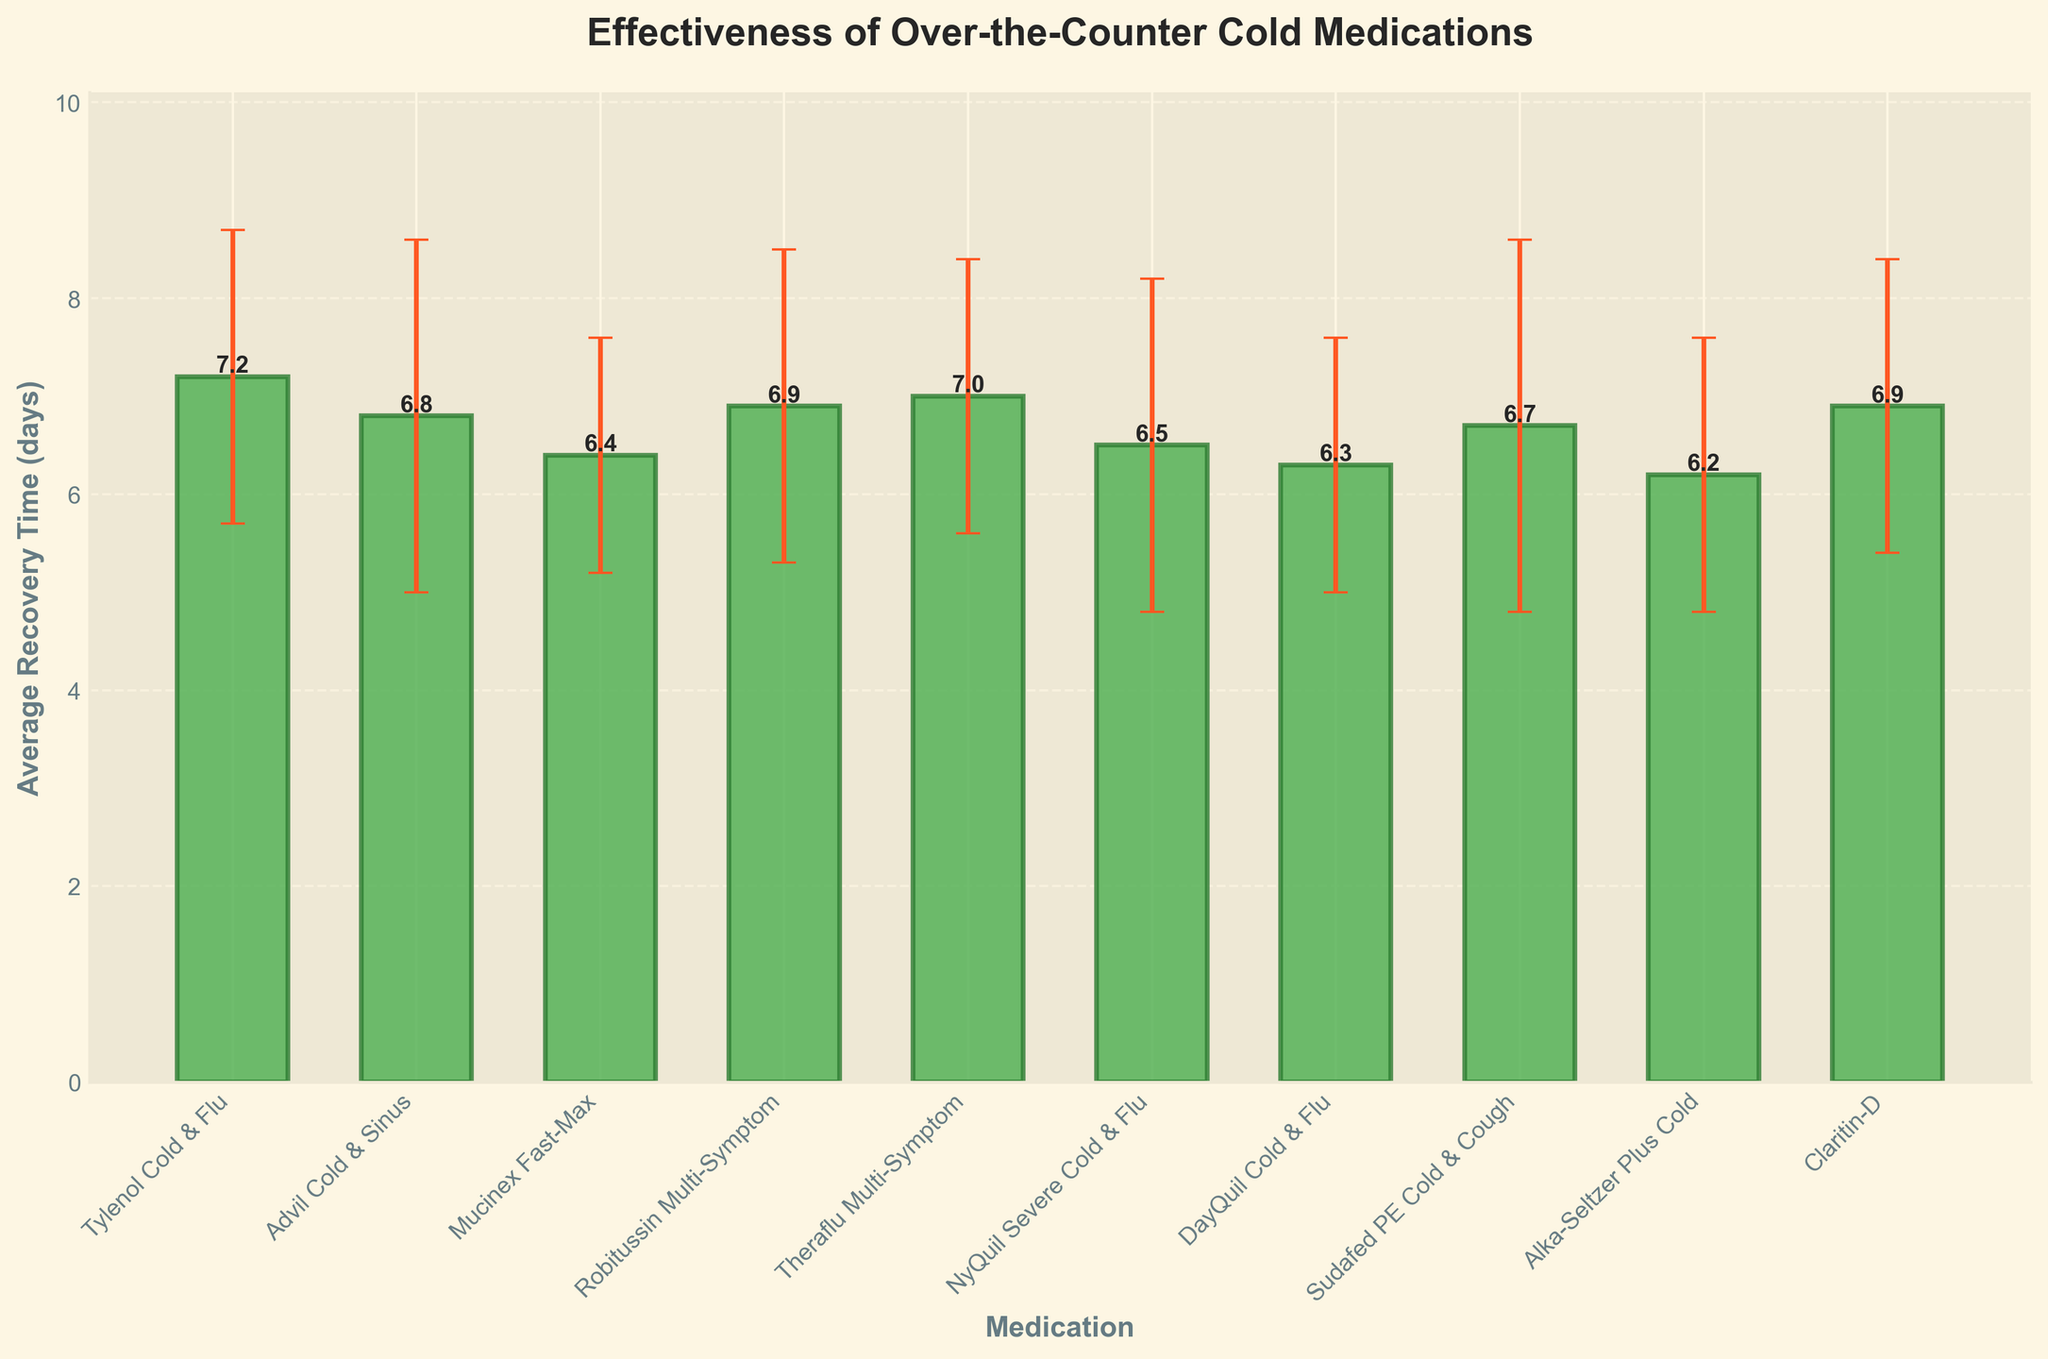What is the medication with the shortest average recovery time? The bar representing DayQuil Cold & Flu has the shortest height, which indicates the shortest average recovery time.
Answer: DayQuil Cold & Flu Which medication has the largest standard deviation in recovery time? The error bar on the bar representing Sudafed PE Cold & Cough is the tallest compared to the other error bars.
Answer: Sudafed PE Cold & Cough How many medications have an average recovery time below 7 days? Count the bars that fall below the 7-day mark on the y-axis: Advil Cold & Sinus, Mucinex Fast-Max, Robitussin Multi-Symptom, NyQuil Severe Cold & Flu, DayQuil Cold & Flu, Sudafed PE Cold & Cough, and Alka-Seltzer Plus Cold.
Answer: 7 What is the range of average recovery times for these medications? Subtract the smallest average recovery time (DayQuil Cold & Flu: 6.3 days) from the largest average recovery time (Tylenol Cold & Flu: 7.2 days).
Answer: 0.9 days Is there any medication with an average recovery time of exactly 7 days? Look for any bars that align with the 7-day mark on the y-axis and check the labels: Theraflu Multi-Symptom is at 7 days.
Answer: Yes, Theraflu Multi-Symptom Which medication has the lowest average recovery time? The bar representing Alka-Seltzer Plus Cold has the lowest height, which indicates the lowest average recovery time.
Answer: Alka-Seltzer Plus Cold How does the average recovery time of Robitussin Multi-Symptom compare to the average recovery time of NyQuil Severe Cold & Flu? Compare the heights of the bars: Robitussin Multi-Symptom's bar is slightly higher than NyQuil Severe Cold & Flu's bar.
Answer: Robitussin Multi-Symptom is higher What is the average of the highest and lowest average recovery times displayed? Identify the highest (7.2 days for Tylenol Cold & Flu) and the lowest (6.2 days for Alka-Seltzer Plus Cold) average recovery times. The average is (7.2 + 6.2) / 2.
Answer: 6.7 days Between DayQuil Cold & Flu and Tylenol Cold & Flu, which has a smaller standard deviation? Compare the error bars visually: The error bar of DayQuil Cold & Flu is shorter than that of Tylenol Cold & Flu.
Answer: DayQuil Cold & Flu 